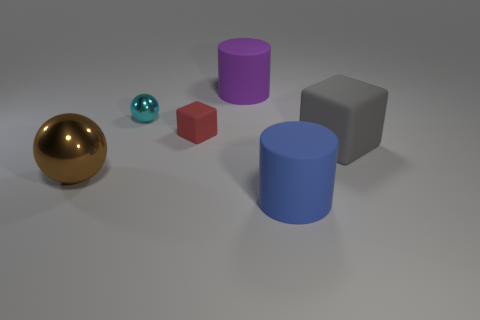Are there any big matte things on the right side of the large rubber cylinder that is in front of the rubber cube to the right of the purple rubber cylinder?
Your response must be concise. Yes. Is the number of large matte objects in front of the red rubber thing greater than the number of gray rubber objects behind the big shiny ball?
Your answer should be compact. Yes. What material is the gray block that is the same size as the purple object?
Keep it short and to the point. Rubber. How many big objects are purple metal cylinders or cyan objects?
Offer a very short reply. 0. Do the small cyan metal thing and the purple rubber object have the same shape?
Ensure brevity in your answer.  No. How many rubber blocks are behind the gray block and right of the purple matte cylinder?
Offer a terse response. 0. What is the shape of the gray object that is the same material as the blue cylinder?
Provide a short and direct response. Cube. Do the cyan ball and the red block have the same size?
Provide a succinct answer. Yes. Do the cylinder in front of the large gray matte block and the big gray cube have the same material?
Offer a terse response. Yes. There is a rubber cube that is on the left side of the big matte cylinder behind the cyan metallic object; what number of big objects are right of it?
Your answer should be very brief. 3. 